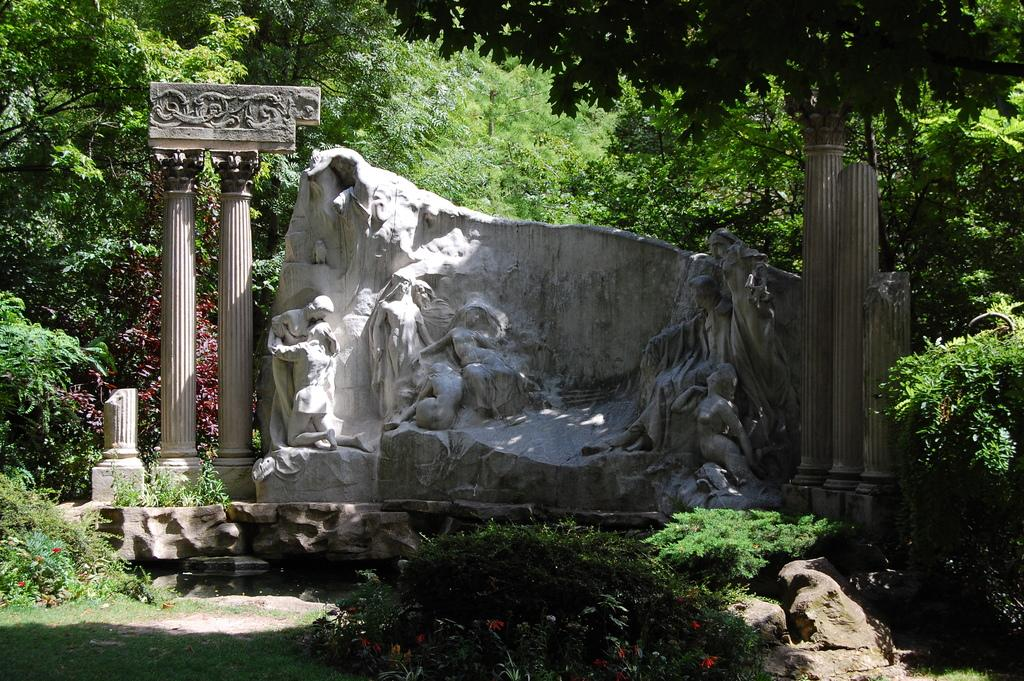What type of architectural feature can be seen in the image? There are pillars in the image. What other structures are present in the image? There are statues on stone in the image. Are there any other objects visible in the image? Yes, there are other objects in the image. What can be seen in the background of the image? There are many trees in the background of the image. What type of vegetation is visible at the bottom of the image? There is grass and plants visible at the bottom of the image. What year is depicted in the image? The image does not depict a specific year; it is a static representation of the architectural features and objects present. Can you see any blood in the image? There is no blood visible in the image. 